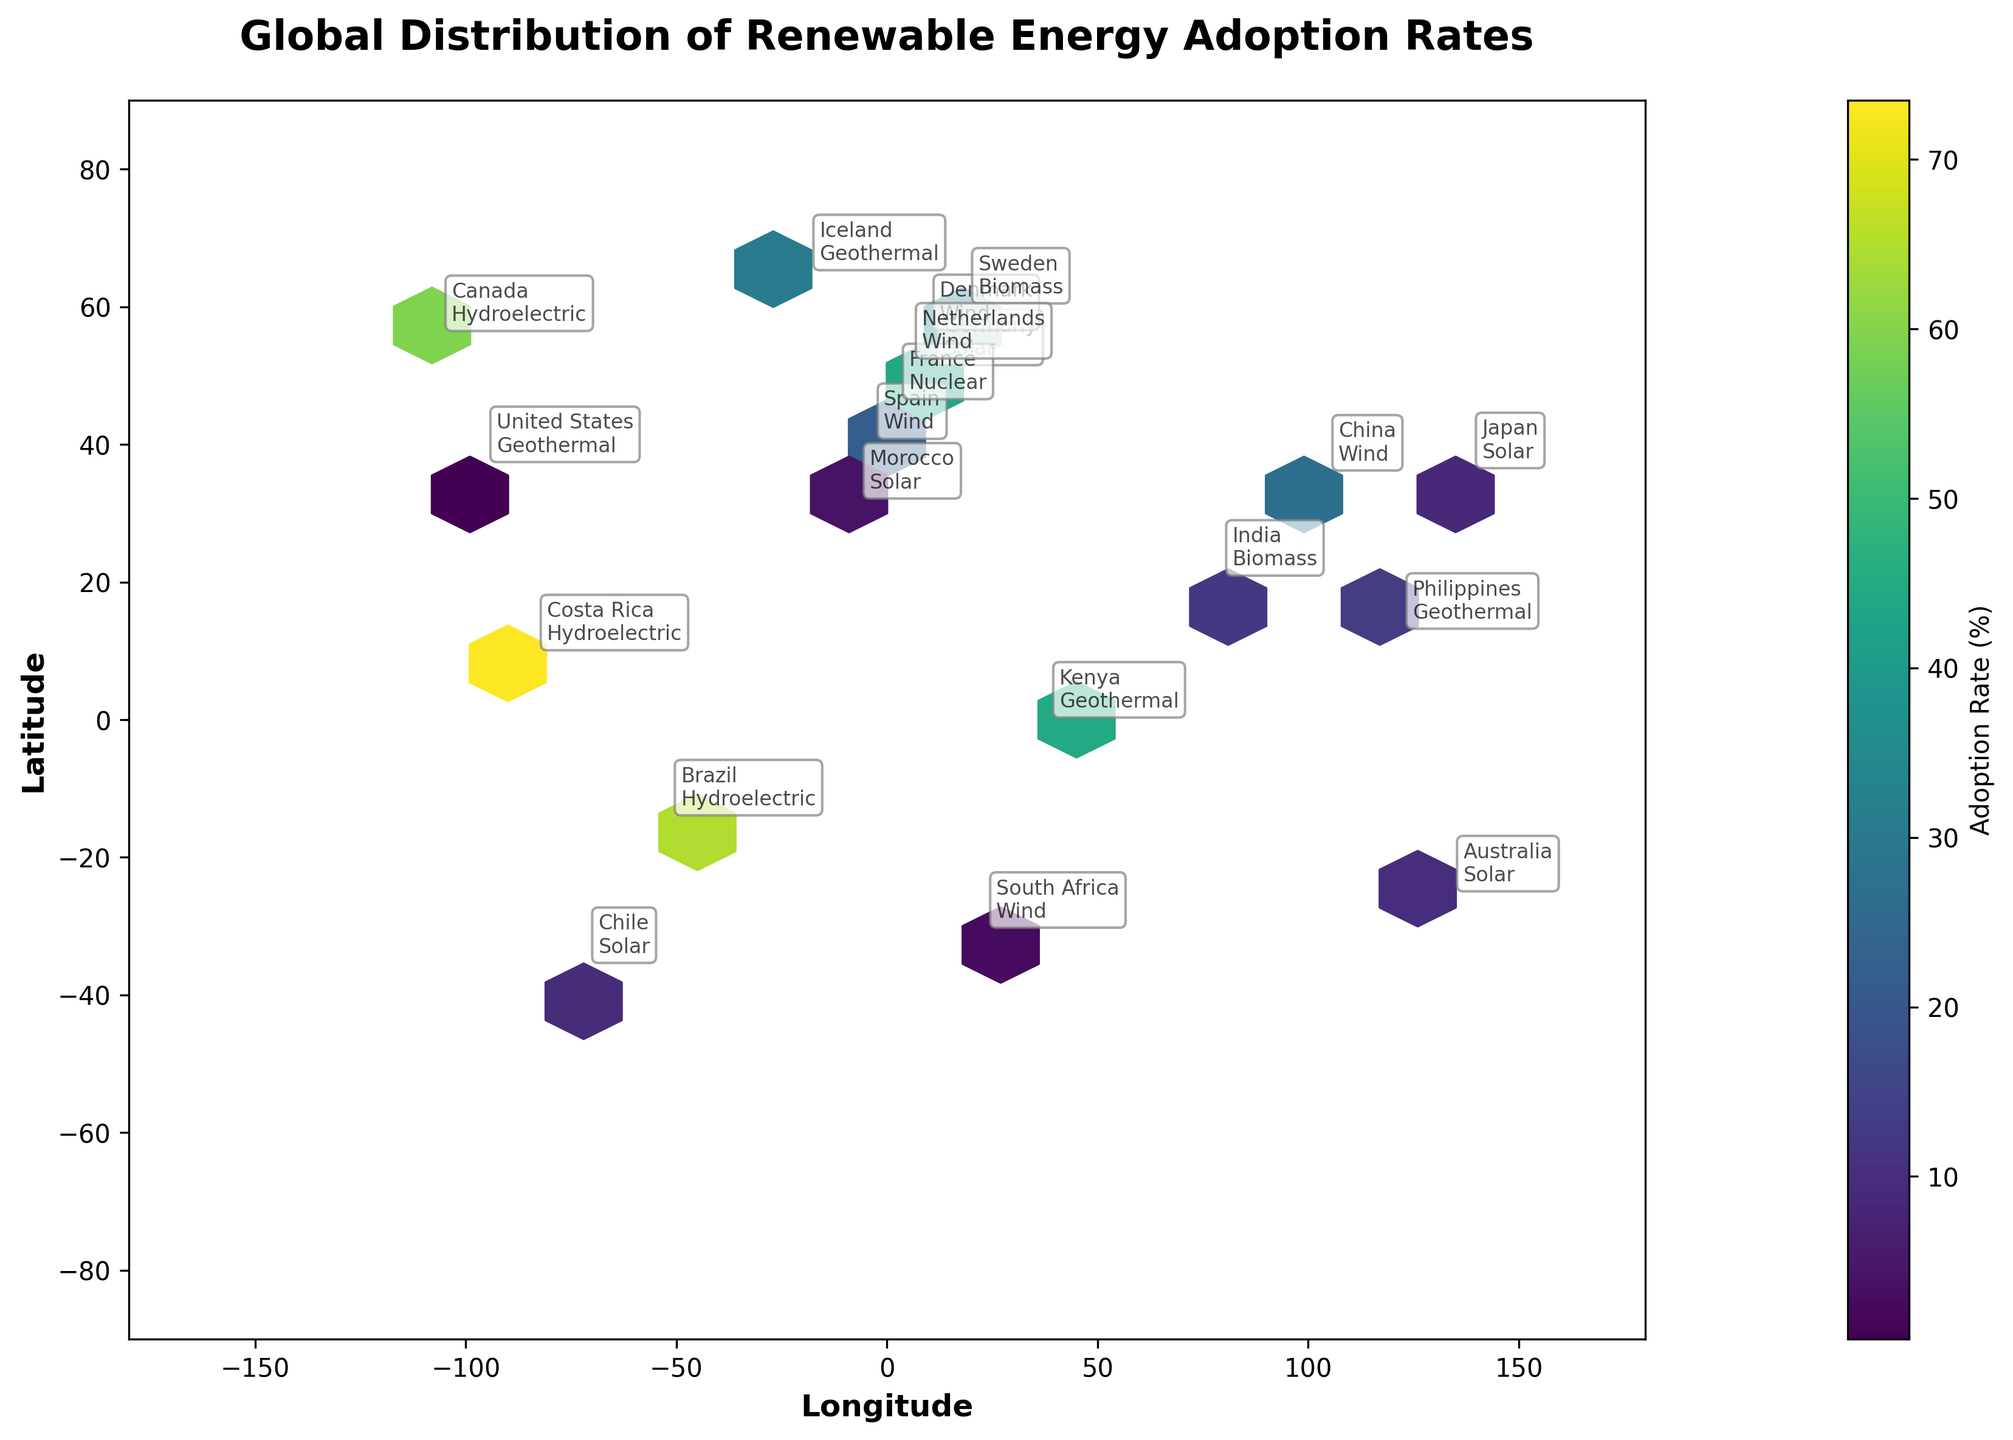What is the range of adoption rates visible in the plot? The color bar labeled 'Adoption Rate (%)' on the right side of the plot indicates the range of adoption rates. It starts at a low value (dark purple) and ends at a high value (yellow). The exact range is not specified in the figure, but it can be inferred from the data points varying from around 0.4% to 73.5%.
Answer: Approximately 0.4% to 73.5% Which country has the highest adoption rate of renewable energy, and what type of energy is it? By looking at the annotated points on the plot and referring to the values provided, Costa Rica has the highest adoption rate of 73.5% and the type of energy is Hydroelectric.
Answer: Costa Rica, Hydroelectric How does the adoption rate of solar energy in Germany compare to the adoption rate of solar energy in Morocco? Germany has a labeled adoption rate of 49.3% for solar energy, while Morocco has a labeled adoption rate of 3.9% for solar energy.
Answer: Germany has a significantly higher adoption rate for solar energy than Morocco What are the coordinates of the country with the lowest adoption rate in the plot, and what type of energy is it? The United States is annotated with a 0.4% adoption rate and is situated around the coordinates (37.0902, -95.7129). The type of energy is Geothermal.
Answer: (37.0902, -95.7129), Geothermal Compare the wind energy adoption rates in China, Denmark, and South Africa. Which one is the highest? By referring to the plot, China's adoption rate for wind energy is 26.7%, Denmark's is 56.9%, and South Africa's is 2.6%. Denmark has the highest adoption rate for wind energy among the three countries.
Answer: Denmark Which region has the densest concentration of adoption rates on the plot? The hexbin plot will show regions with a higher concentration of data points by more vibrant colors. Visual inspection shows that the region around Europe (centered around Germany, Denmark, and the Netherlands) appears to have a high concentration.
Answer: Europe Identify the types of renewable energy adopted by countries in the Southern Hemisphere. By observing the plot annotations provided, countries in the Southern Hemisphere (such as Brazil, Kenya, Australia, Chile, and South Africa) have adopted Hydroelectric, Geothermal, Solar, and Wind energies.
Answer: Hydroelectric, Geothermal, Solar, Wind 